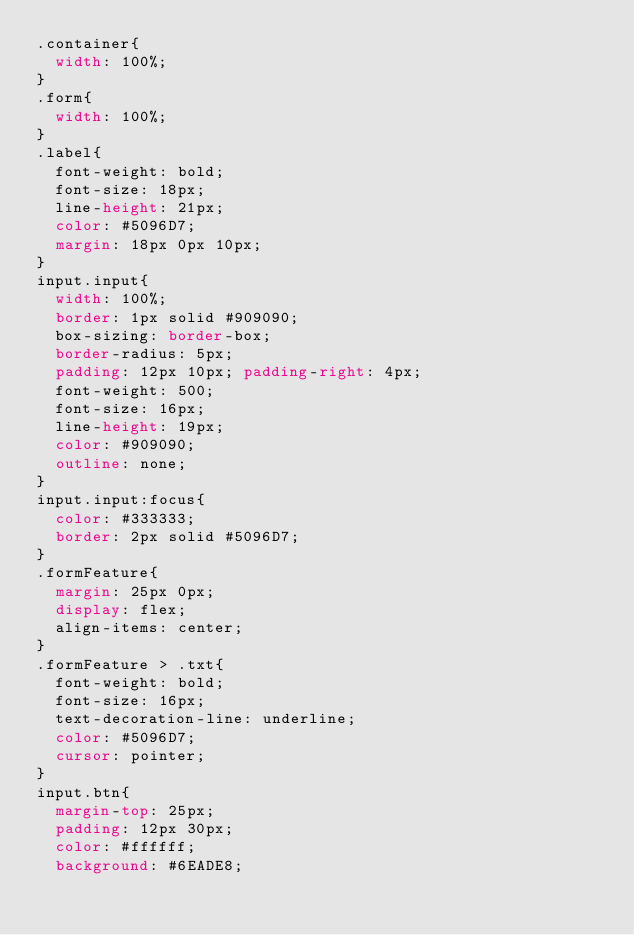Convert code to text. <code><loc_0><loc_0><loc_500><loc_500><_CSS_>.container{
  width: 100%;
}
.form{
  width: 100%;
}
.label{
  font-weight: bold;
  font-size: 18px;
  line-height: 21px;
  color: #5096D7;
  margin: 18px 0px 10px;
}
input.input{
  width: 100%;  
  border: 1px solid #909090;
  box-sizing: border-box;
  border-radius: 5px;
  padding: 12px 10px; padding-right: 4px;
  font-weight: 500;
  font-size: 16px;
  line-height: 19px;
  color: #909090;
  outline: none;
}
input.input:focus{
  color: #333333;
  border: 2px solid #5096D7;
}
.formFeature{
  margin: 25px 0px;
  display: flex;
  align-items: center;
}
.formFeature > .txt{
  font-weight: bold;
  font-size: 16px;
  text-decoration-line: underline;
  color: #5096D7;
  cursor: pointer;
}
input.btn{  
  margin-top: 25px;
  padding: 12px 30px;
  color: #ffffff;
  background: #6EADE8;</code> 